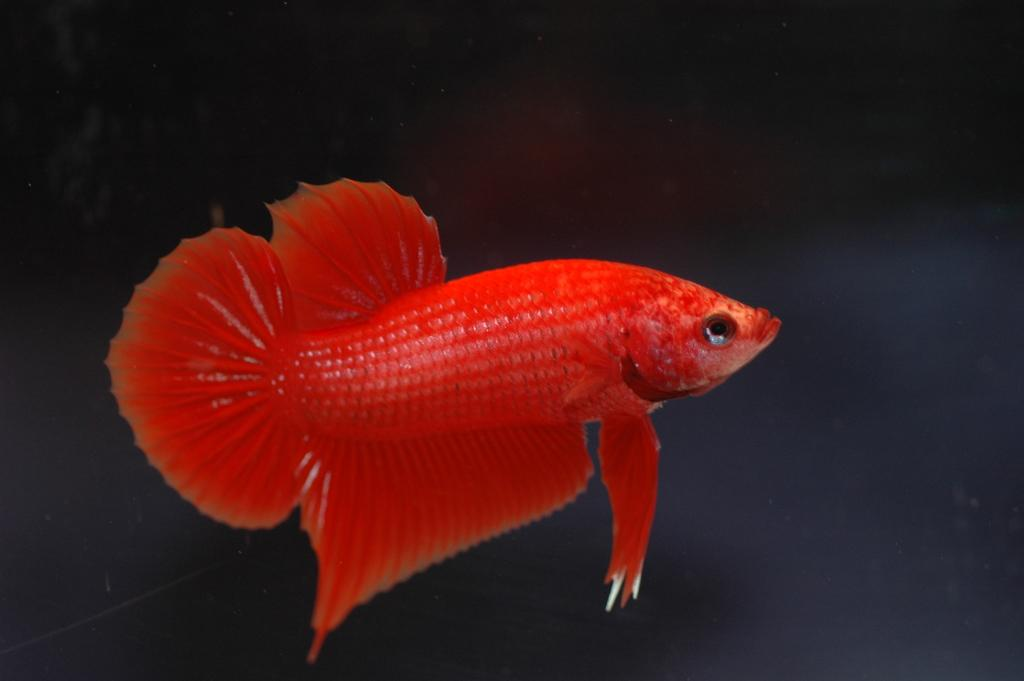What type of animal is in the image? There is a red color fish in the image. What can be observed about the background of the image? The background of the image is dark in color. What type of land feature is present in the image? There is no land feature present in the image, as it features a fish in a dark background. How does the fish express anger in the image? The fish does not express anger in the image, as it is a still image and does not depict emotions. 